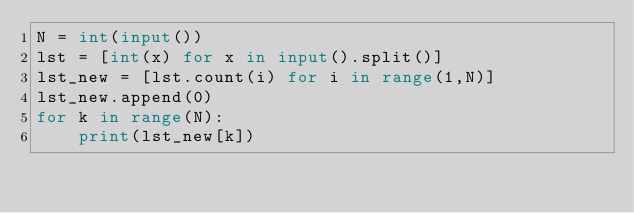<code> <loc_0><loc_0><loc_500><loc_500><_Python_>N = int(input())
lst = [int(x) for x in input().split()]
lst_new = [lst.count(i) for i in range(1,N)]
lst_new.append(0)
for k in range(N):
    print(lst_new[k])</code> 